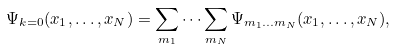<formula> <loc_0><loc_0><loc_500><loc_500>\Psi _ { { k } = 0 } ( { x } _ { 1 } , \dots , { x } _ { N } ) = \sum _ { { m } _ { 1 } } \dots \sum _ { { m } _ { N } } \Psi _ { { m } _ { 1 } \dots { m } _ { N } } ( { x } _ { 1 } , \dots , { x } _ { N } ) ,</formula> 